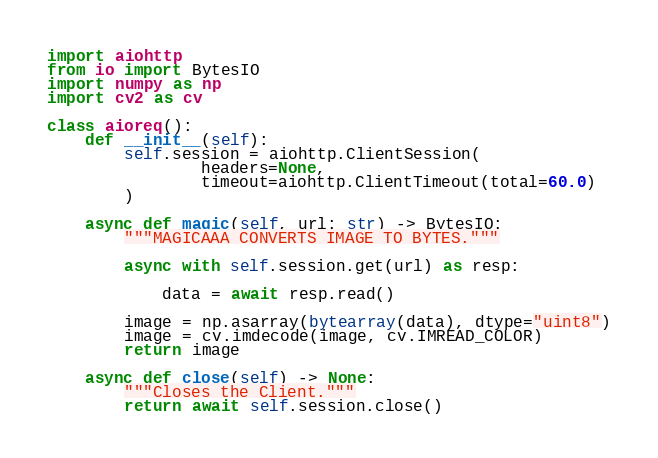<code> <loc_0><loc_0><loc_500><loc_500><_Python_>import aiohttp
from io import BytesIO
import numpy as np
import cv2 as cv

class aioreq():
    def __init__(self):
        self.session = aiohttp.ClientSession(
                headers=None,
                timeout=aiohttp.ClientTimeout(total=60.0)
        )        

    async def magic(self, url: str) -> BytesIO:
        """MAGICAAA CONVERTS IMAGE TO BYTES."""

        async with self.session.get(url) as resp:

            data = await resp.read()

        image = np.asarray(bytearray(data), dtype="uint8")
        image = cv.imdecode(image, cv.IMREAD_COLOR)
        return image

    async def close(self) -> None:
        """Closes the Client."""
        return await self.session.close()
</code> 